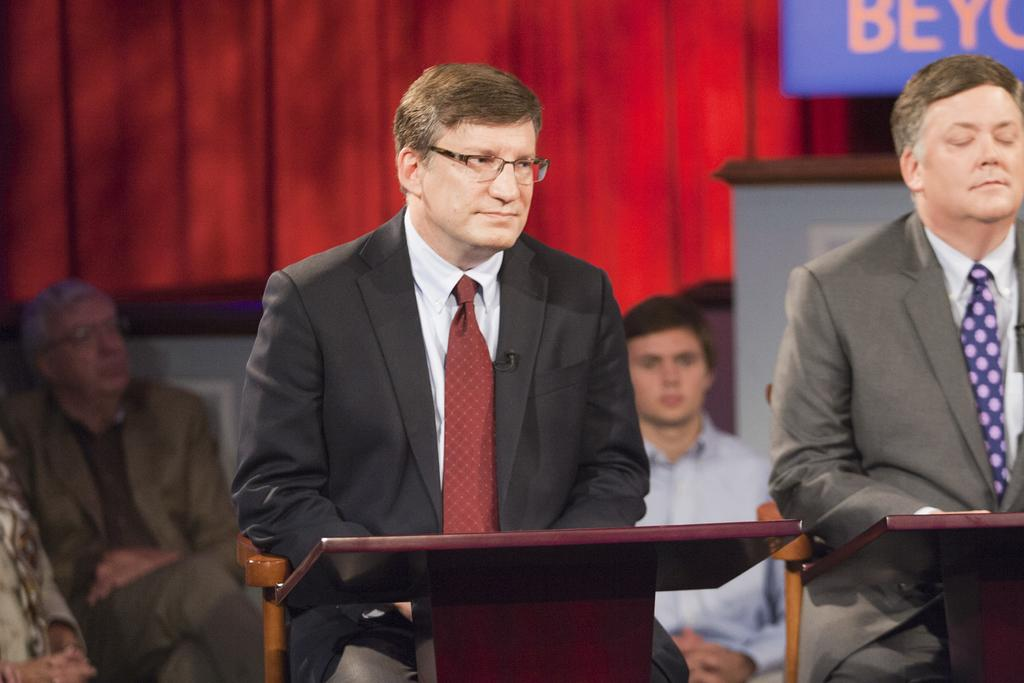What are the people in the image doing? The people are sitting and watching something. What can be seen in the background of the image? There is a curtain visible in the image. Is there any signage or decoration in the image? Yes, there is a banner in the image. What type of breakfast is being served in the image? There is no breakfast visible in the image. Can you tell me how deep the quicksand is in the image? There is no quicksand present in the image. 